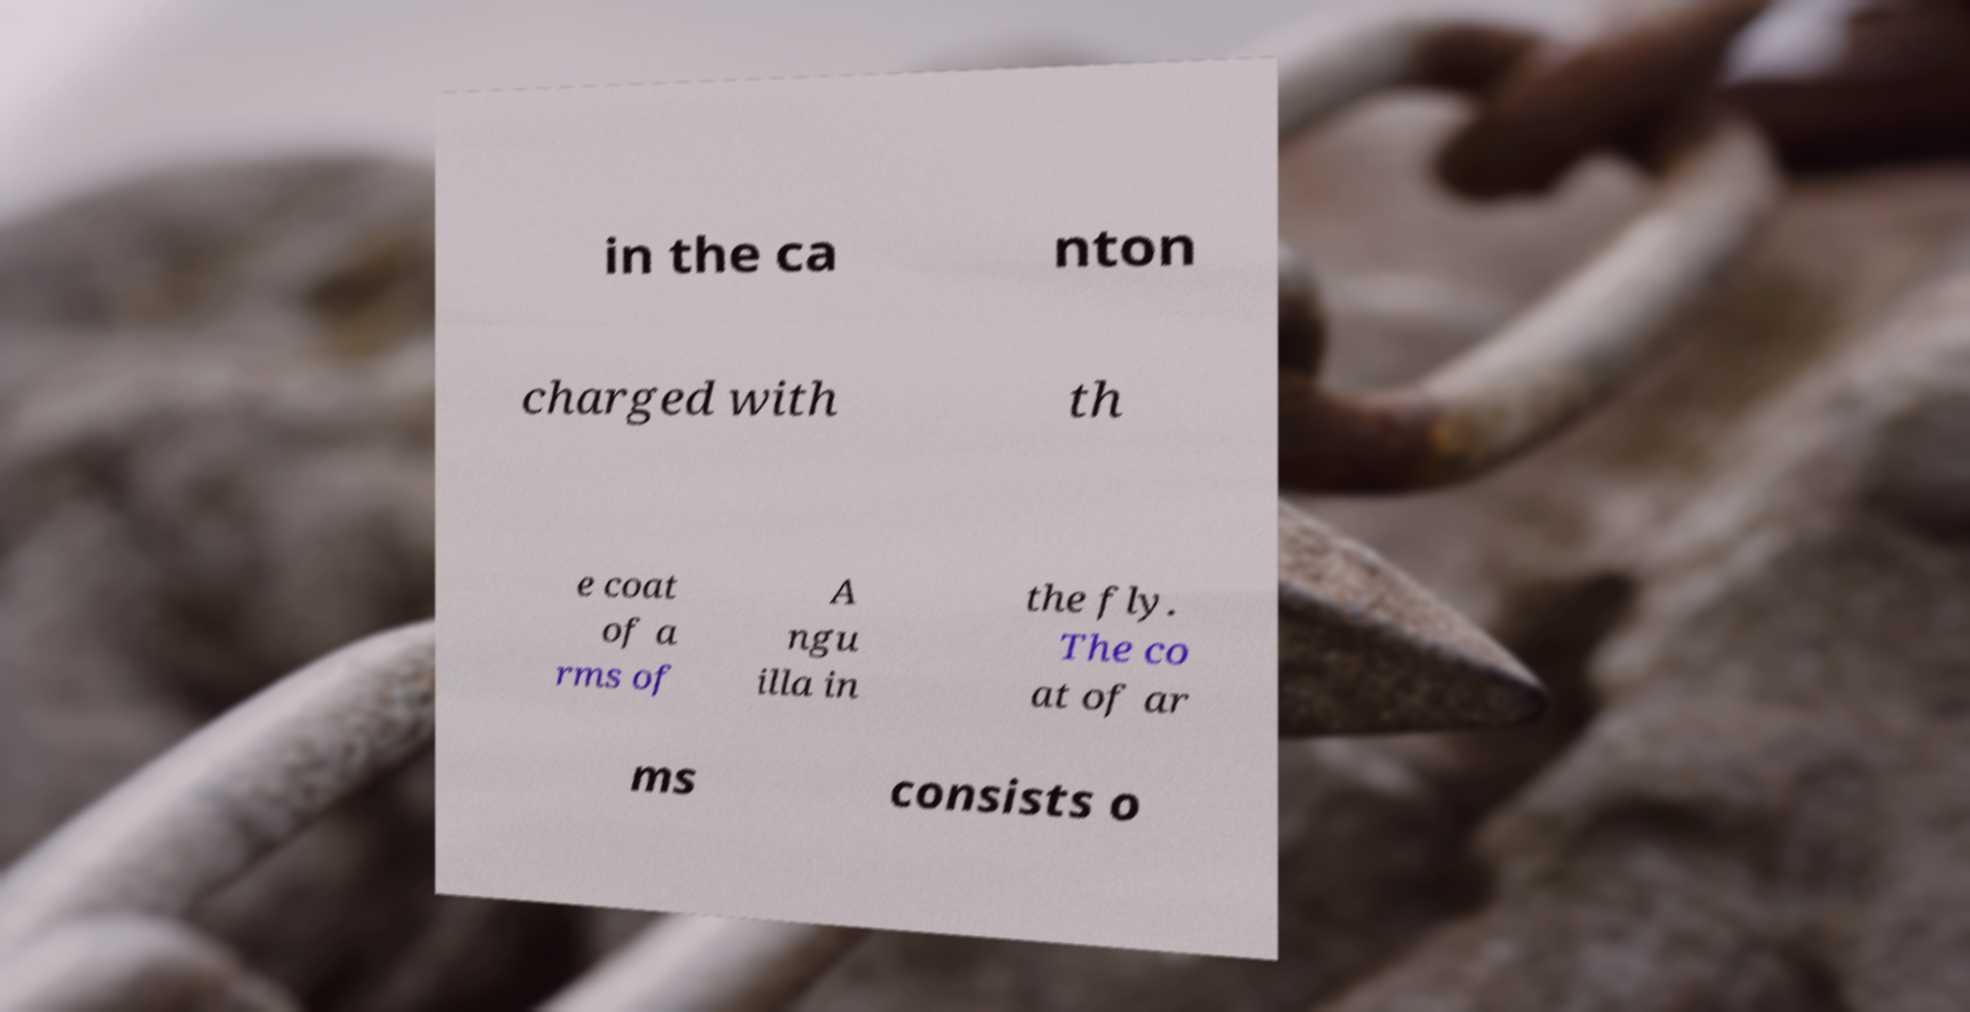Can you accurately transcribe the text from the provided image for me? in the ca nton charged with th e coat of a rms of A ngu illa in the fly. The co at of ar ms consists o 